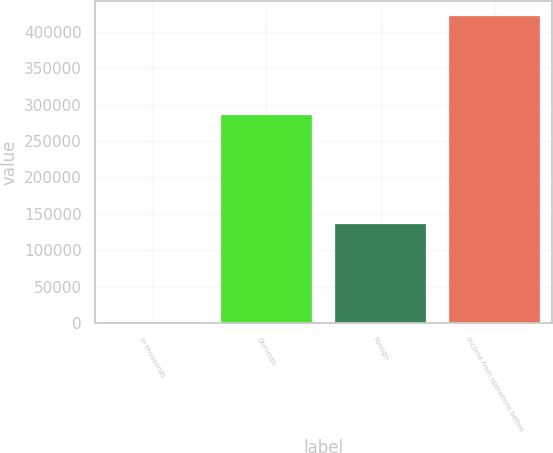<chart> <loc_0><loc_0><loc_500><loc_500><bar_chart><fcel>In thousands<fcel>Domestic<fcel>Foreign<fcel>Income from operations before<nl><fcel>2013<fcel>285395<fcel>135692<fcel>421087<nl></chart> 